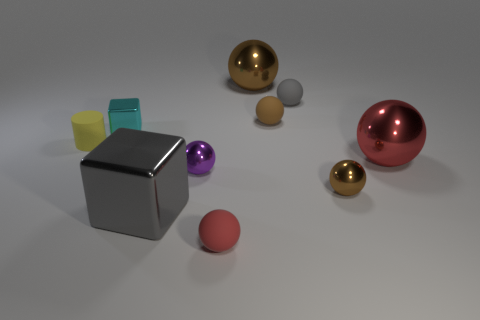What is the shape of the red thing behind the big gray metal cube? The red object positioned behind the large gray cube is a sphere, exhibiting a perfectly round and three-dimensional geometric structure. 